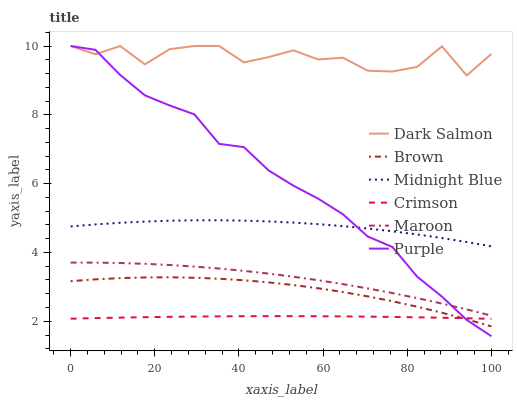Does Crimson have the minimum area under the curve?
Answer yes or no. Yes. Does Dark Salmon have the maximum area under the curve?
Answer yes or no. Yes. Does Midnight Blue have the minimum area under the curve?
Answer yes or no. No. Does Midnight Blue have the maximum area under the curve?
Answer yes or no. No. Is Crimson the smoothest?
Answer yes or no. Yes. Is Dark Salmon the roughest?
Answer yes or no. Yes. Is Midnight Blue the smoothest?
Answer yes or no. No. Is Midnight Blue the roughest?
Answer yes or no. No. Does Midnight Blue have the lowest value?
Answer yes or no. No. Does Dark Salmon have the highest value?
Answer yes or no. Yes. Does Midnight Blue have the highest value?
Answer yes or no. No. Is Maroon less than Dark Salmon?
Answer yes or no. Yes. Is Maroon greater than Crimson?
Answer yes or no. Yes. Does Maroon intersect Purple?
Answer yes or no. Yes. Is Maroon less than Purple?
Answer yes or no. No. Is Maroon greater than Purple?
Answer yes or no. No. Does Maroon intersect Dark Salmon?
Answer yes or no. No. 